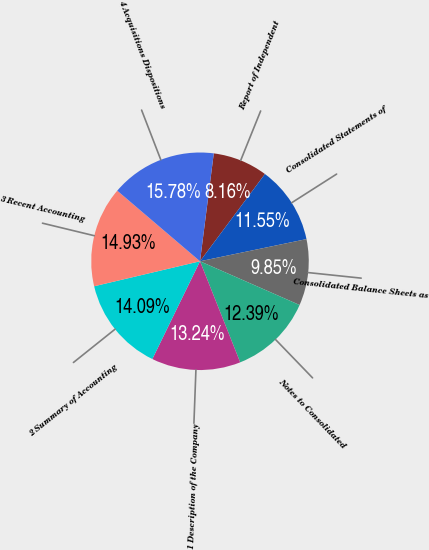Convert chart. <chart><loc_0><loc_0><loc_500><loc_500><pie_chart><fcel>Report of Independent<fcel>Consolidated Statements of<fcel>Consolidated Balance Sheets as<fcel>Notes to Consolidated<fcel>1 Description of the Company<fcel>2 Summary of Accounting<fcel>3 Recent Accounting<fcel>4 Acquisitions Dispositions<nl><fcel>8.16%<fcel>11.55%<fcel>9.85%<fcel>12.39%<fcel>13.24%<fcel>14.09%<fcel>14.93%<fcel>15.78%<nl></chart> 